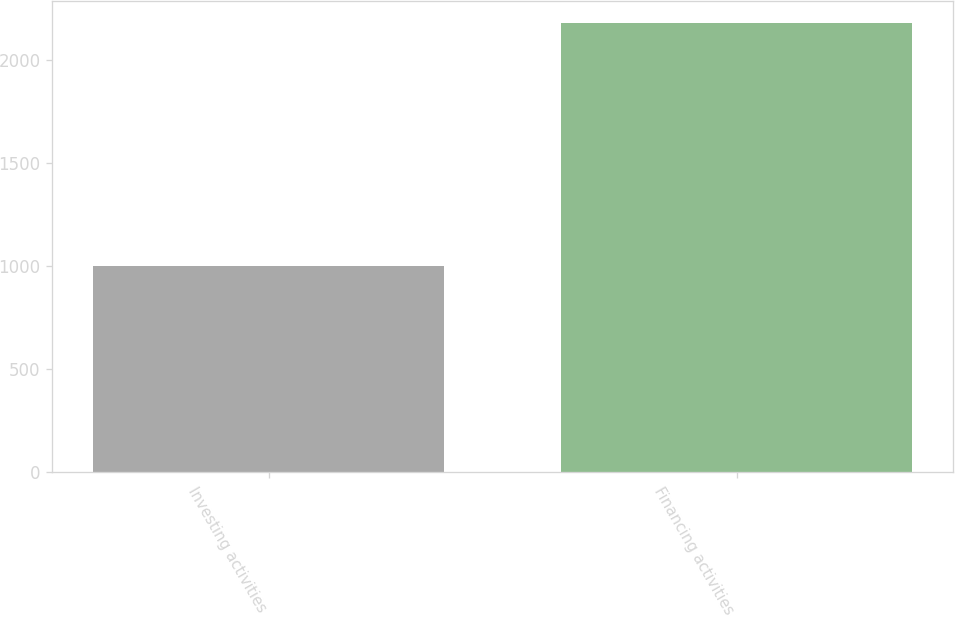Convert chart. <chart><loc_0><loc_0><loc_500><loc_500><bar_chart><fcel>Investing activities<fcel>Financing activities<nl><fcel>1003<fcel>2179<nl></chart> 